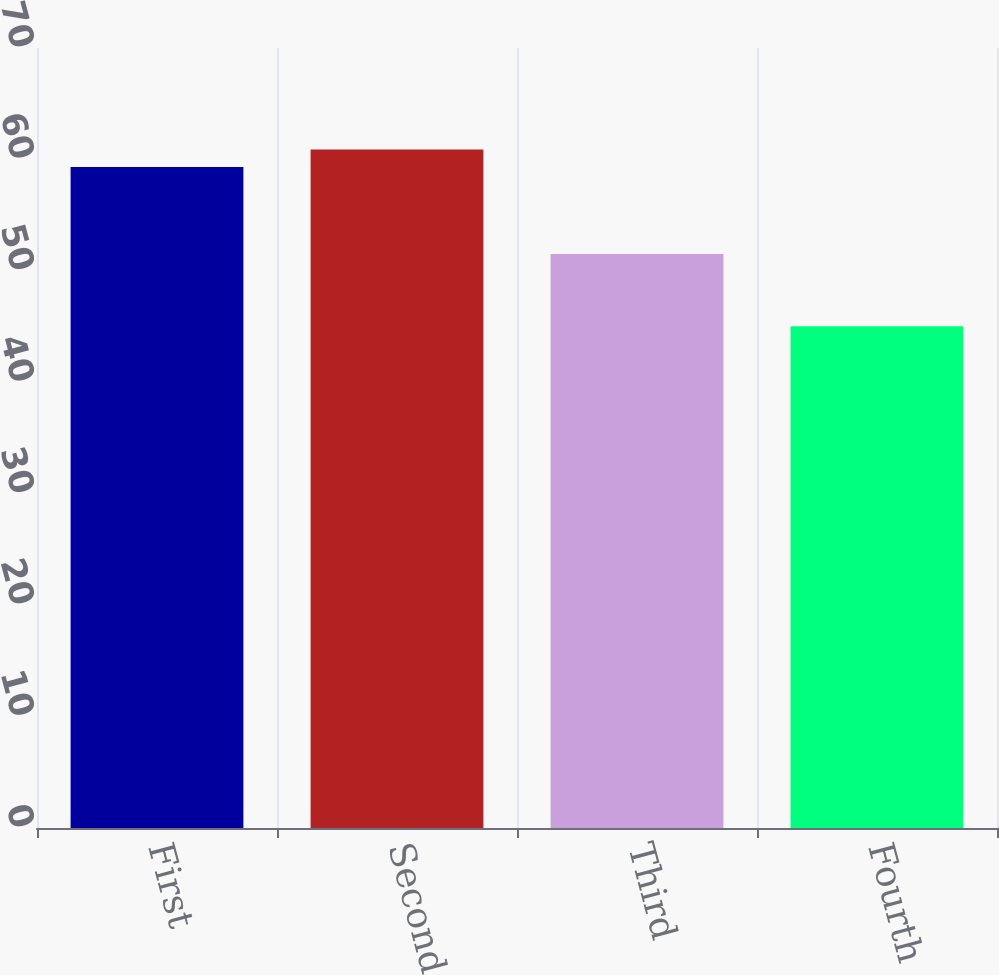<chart> <loc_0><loc_0><loc_500><loc_500><bar_chart><fcel>First<fcel>Second<fcel>Third<fcel>Fourth<nl><fcel>59.33<fcel>60.88<fcel>51.51<fcel>45.04<nl></chart> 